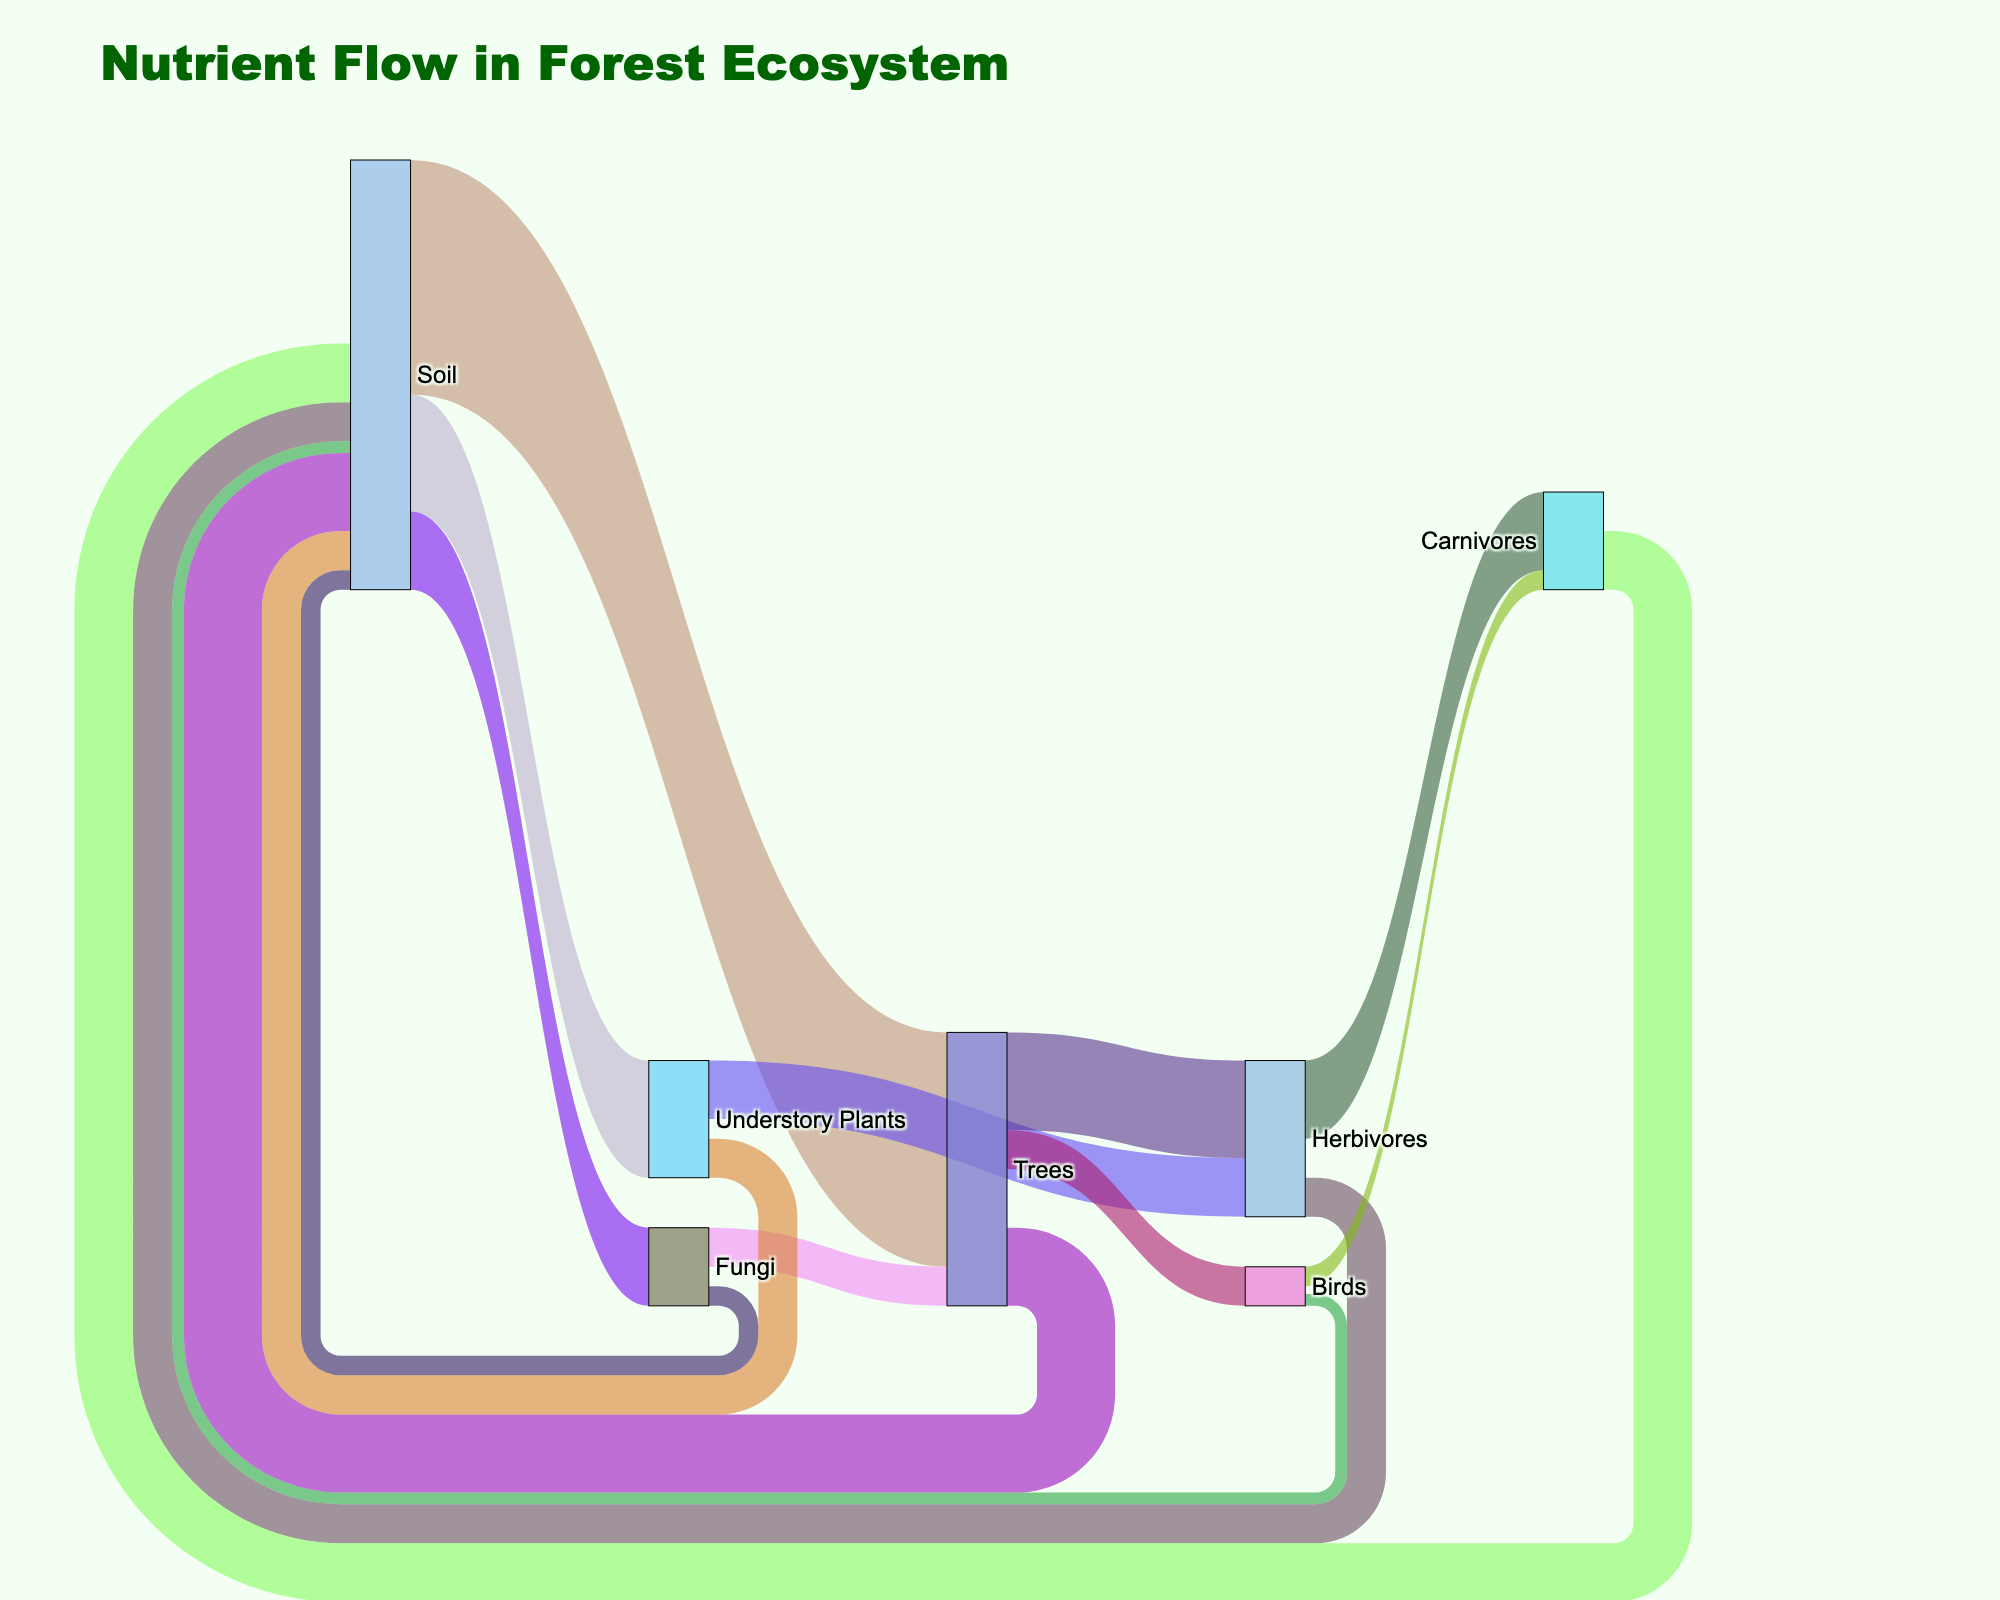How many types of elements are labeled in the nutrient flow? The Sankey diagram shows labeled elements such as Soil, Understory Plants, Trees, Fungi, Herbivores, Birds, Carnivores. Counting these unique labels gives the total number of element types.
Answer: Seven What's the main source of nutrients for Trees? By observing the width of the connections flowing into Trees, the largest nutrient source can be identified. The width of the flow from Soil to Trees is 60, which is larger than any other source connected to Trees.
Answer: Soil Which nutrient flow connection has the smallest value in the diagram? Look for the thinnest line in the Sankey diagram which represents the smallest value. The connection from Birds to Soil has a value of 3, which is the smallest.
Answer: Birds to Soil How is the nutrient flow distributed among Carnivores? Identify all flows going to Carnivores, which are from Herbivores (20) and Birds (5). The total is then 25.
Answer: 20 from Herbivores and 5 from Birds What is the total amount of nutrients returned to the Soil? Add up all nutrient flows directed towards the Soil: from Herbivores (10), Birds (3), Carnivores (15), Trees (20), Understory Plants (10), and Fungi (5). The sum is 10 + 3 + 15 + 20 + 10 + 5 = 63.
Answer: 63 Compare the nutrient flow from Soil to Understory Plants and Soil to Fungi. Which is greater? The diagram shows the nutrient flow values: Soil to Understory Plants is 30 and Soil to Fungi is 20. By comparing these values, it's clear that the flow from Soil to Understory Plants is greater.
Answer: Soil to Understory Plants What proportion of nutrients do Trees receive compared to the total nutrients flowing to Understory Plants and Trees from the Soil? Add the values from Soil to Trees (60) and Soil to Understory Plants (30), giving a total of 90. The proportion for Trees is 60/90, which is approximately 0.67 or 67%.
Answer: 67% What happens to the nutrients after reaching Understory Plants? Refer to the flows coming out from Understory Plants: 15 to Herbivores and 10 back to Soil. Summarizing this, Understory Plants distribute their nutrients to Herbivores and Soil.
Answer: 15 to Herbivores and 10 to Soil Which organism receives nutrients directly from both Trees and Understory Plants? Examine the connections coming out from Trees and Understory Plants. Herbivores receive nutrients from both sources: 25 from Trees and 15 from Understory Plants.
Answer: Herbivores How many nutrients do Fungi transfer to Trees, and how is it contrasted with the amount Trees return to Soil? From the diagram, Fungi transfer 10 nutrients to Trees. Trees return 20 nutrients to the Soil. Comparing these flows shows that Trees return twice the nutrients to Soil than they receive from Fungi.
Answer: 10 to Trees, 20 to Soil 